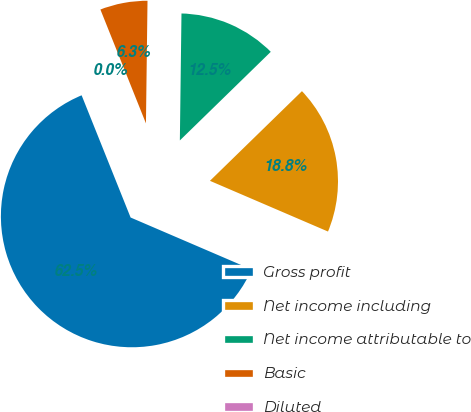Convert chart. <chart><loc_0><loc_0><loc_500><loc_500><pie_chart><fcel>Gross profit<fcel>Net income including<fcel>Net income attributable to<fcel>Basic<fcel>Diluted<nl><fcel>62.47%<fcel>18.75%<fcel>12.5%<fcel>6.26%<fcel>0.01%<nl></chart> 